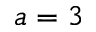<formula> <loc_0><loc_0><loc_500><loc_500>a = 3</formula> 